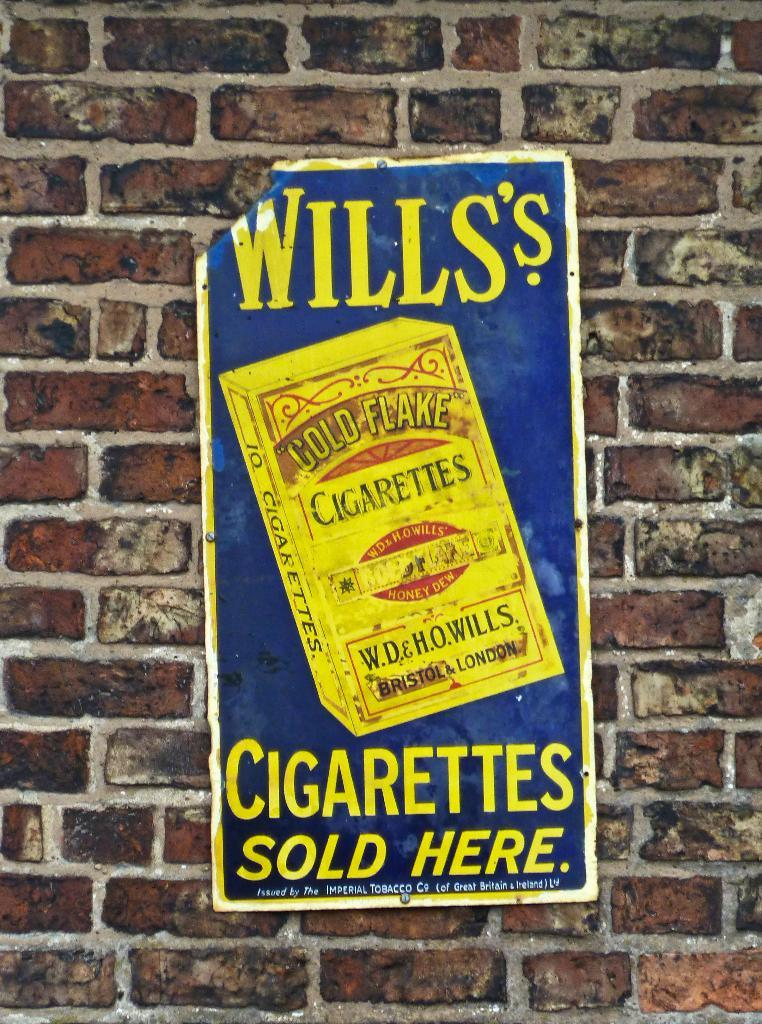<image>
Summarize the visual content of the image. A sign for Wills's cigarettes hangs on a brick wall and indicates you can buy the product here. 